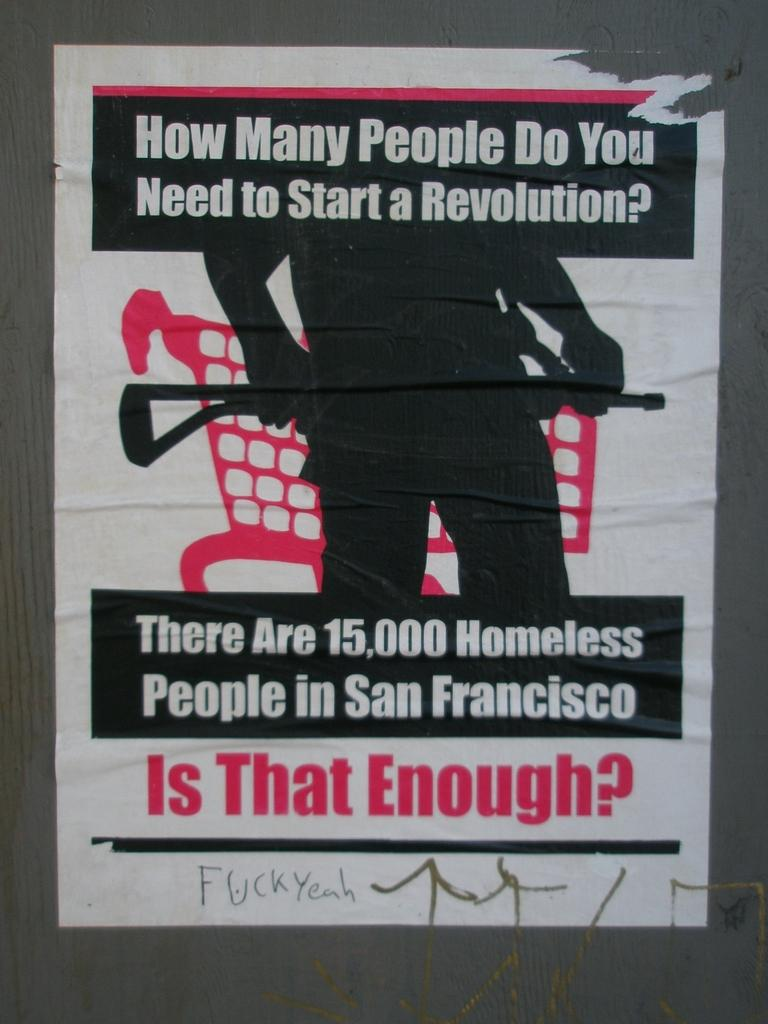What is present on the wall in the image? There is a poster on the wall in the image. How is the poster attached to the wall? The poster is attached to the wall. What can be found on the poster besides the image of a person? There is text on the poster. Can you tell me how many snails are crawling on the poster in the image? There are no snails present on the poster in the image. What type of lunchroom is shown in the image? The image does not show a lunchroom; it only features a poster with an image of a person and text. 